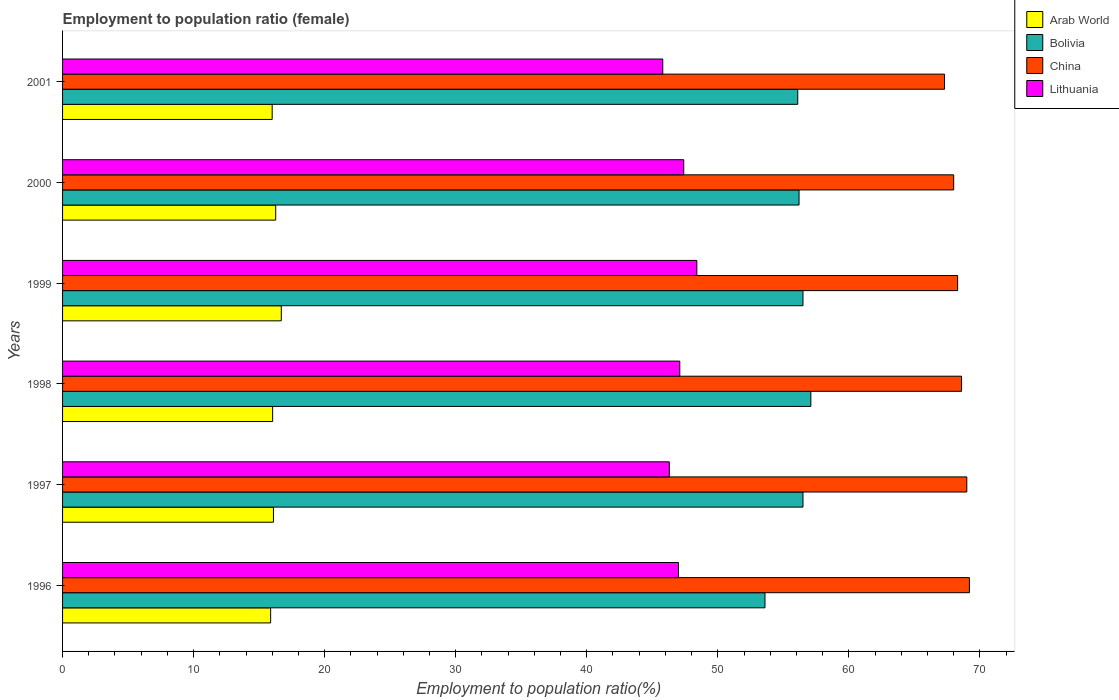How many different coloured bars are there?
Offer a very short reply. 4. What is the label of the 4th group of bars from the top?
Keep it short and to the point. 1998. What is the employment to population ratio in Bolivia in 1996?
Your answer should be very brief. 53.6. Across all years, what is the maximum employment to population ratio in Bolivia?
Ensure brevity in your answer.  57.1. Across all years, what is the minimum employment to population ratio in Arab World?
Keep it short and to the point. 15.88. In which year was the employment to population ratio in Lithuania minimum?
Ensure brevity in your answer.  2001. What is the total employment to population ratio in Arab World in the graph?
Give a very brief answer. 96.95. What is the difference between the employment to population ratio in Bolivia in 1996 and that in 1999?
Keep it short and to the point. -2.9. What is the difference between the employment to population ratio in China in 2000 and the employment to population ratio in Lithuania in 1999?
Your response must be concise. 19.6. What is the average employment to population ratio in Arab World per year?
Your answer should be very brief. 16.16. In the year 1996, what is the difference between the employment to population ratio in Bolivia and employment to population ratio in Lithuania?
Offer a terse response. 6.6. What is the ratio of the employment to population ratio in Lithuania in 1999 to that in 2001?
Your answer should be compact. 1.06. What is the difference between the highest and the second highest employment to population ratio in China?
Your response must be concise. 0.2. What is the difference between the highest and the lowest employment to population ratio in Lithuania?
Offer a very short reply. 2.6. In how many years, is the employment to population ratio in Lithuania greater than the average employment to population ratio in Lithuania taken over all years?
Ensure brevity in your answer.  4. Is the sum of the employment to population ratio in Arab World in 1997 and 1999 greater than the maximum employment to population ratio in Bolivia across all years?
Give a very brief answer. No. Are all the bars in the graph horizontal?
Your response must be concise. Yes. Are the values on the major ticks of X-axis written in scientific E-notation?
Your response must be concise. No. Does the graph contain any zero values?
Provide a succinct answer. No. Where does the legend appear in the graph?
Your answer should be compact. Top right. How many legend labels are there?
Keep it short and to the point. 4. How are the legend labels stacked?
Give a very brief answer. Vertical. What is the title of the graph?
Ensure brevity in your answer.  Employment to population ratio (female). What is the Employment to population ratio(%) in Arab World in 1996?
Offer a very short reply. 15.88. What is the Employment to population ratio(%) in Bolivia in 1996?
Provide a short and direct response. 53.6. What is the Employment to population ratio(%) in China in 1996?
Offer a very short reply. 69.2. What is the Employment to population ratio(%) in Arab World in 1997?
Your answer should be very brief. 16.09. What is the Employment to population ratio(%) in Bolivia in 1997?
Keep it short and to the point. 56.5. What is the Employment to population ratio(%) in China in 1997?
Your answer should be compact. 69. What is the Employment to population ratio(%) in Lithuania in 1997?
Your response must be concise. 46.3. What is the Employment to population ratio(%) in Arab World in 1998?
Your answer should be very brief. 16.03. What is the Employment to population ratio(%) of Bolivia in 1998?
Your answer should be very brief. 57.1. What is the Employment to population ratio(%) of China in 1998?
Offer a terse response. 68.6. What is the Employment to population ratio(%) in Lithuania in 1998?
Ensure brevity in your answer.  47.1. What is the Employment to population ratio(%) in Arab World in 1999?
Keep it short and to the point. 16.69. What is the Employment to population ratio(%) of Bolivia in 1999?
Keep it short and to the point. 56.5. What is the Employment to population ratio(%) of China in 1999?
Ensure brevity in your answer.  68.3. What is the Employment to population ratio(%) in Lithuania in 1999?
Make the answer very short. 48.4. What is the Employment to population ratio(%) in Arab World in 2000?
Your answer should be compact. 16.26. What is the Employment to population ratio(%) of Bolivia in 2000?
Offer a terse response. 56.2. What is the Employment to population ratio(%) in Lithuania in 2000?
Keep it short and to the point. 47.4. What is the Employment to population ratio(%) in Arab World in 2001?
Make the answer very short. 16. What is the Employment to population ratio(%) in Bolivia in 2001?
Your answer should be very brief. 56.1. What is the Employment to population ratio(%) of China in 2001?
Provide a short and direct response. 67.3. What is the Employment to population ratio(%) in Lithuania in 2001?
Your response must be concise. 45.8. Across all years, what is the maximum Employment to population ratio(%) in Arab World?
Your answer should be compact. 16.69. Across all years, what is the maximum Employment to population ratio(%) in Bolivia?
Offer a very short reply. 57.1. Across all years, what is the maximum Employment to population ratio(%) of China?
Give a very brief answer. 69.2. Across all years, what is the maximum Employment to population ratio(%) in Lithuania?
Provide a succinct answer. 48.4. Across all years, what is the minimum Employment to population ratio(%) of Arab World?
Keep it short and to the point. 15.88. Across all years, what is the minimum Employment to population ratio(%) in Bolivia?
Your answer should be compact. 53.6. Across all years, what is the minimum Employment to population ratio(%) in China?
Give a very brief answer. 67.3. Across all years, what is the minimum Employment to population ratio(%) in Lithuania?
Provide a short and direct response. 45.8. What is the total Employment to population ratio(%) of Arab World in the graph?
Make the answer very short. 96.95. What is the total Employment to population ratio(%) in Bolivia in the graph?
Your response must be concise. 336. What is the total Employment to population ratio(%) of China in the graph?
Your response must be concise. 410.4. What is the total Employment to population ratio(%) in Lithuania in the graph?
Offer a very short reply. 282. What is the difference between the Employment to population ratio(%) in Arab World in 1996 and that in 1997?
Offer a very short reply. -0.22. What is the difference between the Employment to population ratio(%) in Bolivia in 1996 and that in 1997?
Keep it short and to the point. -2.9. What is the difference between the Employment to population ratio(%) in Arab World in 1996 and that in 1998?
Your answer should be compact. -0.15. What is the difference between the Employment to population ratio(%) in Lithuania in 1996 and that in 1998?
Keep it short and to the point. -0.1. What is the difference between the Employment to population ratio(%) in Arab World in 1996 and that in 1999?
Provide a succinct answer. -0.81. What is the difference between the Employment to population ratio(%) of Bolivia in 1996 and that in 1999?
Offer a terse response. -2.9. What is the difference between the Employment to population ratio(%) in China in 1996 and that in 1999?
Provide a short and direct response. 0.9. What is the difference between the Employment to population ratio(%) in Lithuania in 1996 and that in 1999?
Make the answer very short. -1.4. What is the difference between the Employment to population ratio(%) in Arab World in 1996 and that in 2000?
Ensure brevity in your answer.  -0.39. What is the difference between the Employment to population ratio(%) of Arab World in 1996 and that in 2001?
Make the answer very short. -0.12. What is the difference between the Employment to population ratio(%) of Arab World in 1997 and that in 1998?
Make the answer very short. 0.06. What is the difference between the Employment to population ratio(%) of Bolivia in 1997 and that in 1998?
Ensure brevity in your answer.  -0.6. What is the difference between the Employment to population ratio(%) of China in 1997 and that in 1998?
Offer a terse response. 0.4. What is the difference between the Employment to population ratio(%) of Lithuania in 1997 and that in 1998?
Your answer should be very brief. -0.8. What is the difference between the Employment to population ratio(%) of Arab World in 1997 and that in 1999?
Ensure brevity in your answer.  -0.6. What is the difference between the Employment to population ratio(%) in Bolivia in 1997 and that in 1999?
Your response must be concise. 0. What is the difference between the Employment to population ratio(%) in China in 1997 and that in 1999?
Make the answer very short. 0.7. What is the difference between the Employment to population ratio(%) in Arab World in 1997 and that in 2000?
Make the answer very short. -0.17. What is the difference between the Employment to population ratio(%) of Bolivia in 1997 and that in 2000?
Your answer should be very brief. 0.3. What is the difference between the Employment to population ratio(%) in China in 1997 and that in 2000?
Your answer should be compact. 1. What is the difference between the Employment to population ratio(%) in Lithuania in 1997 and that in 2000?
Make the answer very short. -1.1. What is the difference between the Employment to population ratio(%) in Arab World in 1997 and that in 2001?
Your response must be concise. 0.1. What is the difference between the Employment to population ratio(%) in China in 1997 and that in 2001?
Offer a very short reply. 1.7. What is the difference between the Employment to population ratio(%) in Lithuania in 1997 and that in 2001?
Give a very brief answer. 0.5. What is the difference between the Employment to population ratio(%) in Arab World in 1998 and that in 1999?
Provide a succinct answer. -0.66. What is the difference between the Employment to population ratio(%) in China in 1998 and that in 1999?
Ensure brevity in your answer.  0.3. What is the difference between the Employment to population ratio(%) of Lithuania in 1998 and that in 1999?
Keep it short and to the point. -1.3. What is the difference between the Employment to population ratio(%) in Arab World in 1998 and that in 2000?
Your response must be concise. -0.23. What is the difference between the Employment to population ratio(%) in China in 1998 and that in 2000?
Provide a short and direct response. 0.6. What is the difference between the Employment to population ratio(%) in Lithuania in 1998 and that in 2000?
Ensure brevity in your answer.  -0.3. What is the difference between the Employment to population ratio(%) of Arab World in 1998 and that in 2001?
Offer a terse response. 0.04. What is the difference between the Employment to population ratio(%) of China in 1998 and that in 2001?
Make the answer very short. 1.3. What is the difference between the Employment to population ratio(%) in Arab World in 1999 and that in 2000?
Your answer should be compact. 0.43. What is the difference between the Employment to population ratio(%) of Bolivia in 1999 and that in 2000?
Give a very brief answer. 0.3. What is the difference between the Employment to population ratio(%) of China in 1999 and that in 2000?
Offer a terse response. 0.3. What is the difference between the Employment to population ratio(%) of Arab World in 1999 and that in 2001?
Your answer should be very brief. 0.7. What is the difference between the Employment to population ratio(%) of Bolivia in 1999 and that in 2001?
Ensure brevity in your answer.  0.4. What is the difference between the Employment to population ratio(%) in China in 1999 and that in 2001?
Your answer should be compact. 1. What is the difference between the Employment to population ratio(%) in Arab World in 2000 and that in 2001?
Provide a succinct answer. 0.27. What is the difference between the Employment to population ratio(%) of China in 2000 and that in 2001?
Make the answer very short. 0.7. What is the difference between the Employment to population ratio(%) in Lithuania in 2000 and that in 2001?
Offer a very short reply. 1.6. What is the difference between the Employment to population ratio(%) in Arab World in 1996 and the Employment to population ratio(%) in Bolivia in 1997?
Your answer should be compact. -40.62. What is the difference between the Employment to population ratio(%) of Arab World in 1996 and the Employment to population ratio(%) of China in 1997?
Offer a terse response. -53.12. What is the difference between the Employment to population ratio(%) in Arab World in 1996 and the Employment to population ratio(%) in Lithuania in 1997?
Provide a succinct answer. -30.42. What is the difference between the Employment to population ratio(%) of Bolivia in 1996 and the Employment to population ratio(%) of China in 1997?
Your answer should be very brief. -15.4. What is the difference between the Employment to population ratio(%) in Bolivia in 1996 and the Employment to population ratio(%) in Lithuania in 1997?
Offer a terse response. 7.3. What is the difference between the Employment to population ratio(%) in China in 1996 and the Employment to population ratio(%) in Lithuania in 1997?
Provide a succinct answer. 22.9. What is the difference between the Employment to population ratio(%) of Arab World in 1996 and the Employment to population ratio(%) of Bolivia in 1998?
Your response must be concise. -41.22. What is the difference between the Employment to population ratio(%) of Arab World in 1996 and the Employment to population ratio(%) of China in 1998?
Your response must be concise. -52.72. What is the difference between the Employment to population ratio(%) in Arab World in 1996 and the Employment to population ratio(%) in Lithuania in 1998?
Ensure brevity in your answer.  -31.22. What is the difference between the Employment to population ratio(%) in Bolivia in 1996 and the Employment to population ratio(%) in China in 1998?
Provide a short and direct response. -15. What is the difference between the Employment to population ratio(%) in Bolivia in 1996 and the Employment to population ratio(%) in Lithuania in 1998?
Provide a short and direct response. 6.5. What is the difference between the Employment to population ratio(%) of China in 1996 and the Employment to population ratio(%) of Lithuania in 1998?
Provide a short and direct response. 22.1. What is the difference between the Employment to population ratio(%) of Arab World in 1996 and the Employment to population ratio(%) of Bolivia in 1999?
Provide a succinct answer. -40.62. What is the difference between the Employment to population ratio(%) of Arab World in 1996 and the Employment to population ratio(%) of China in 1999?
Provide a short and direct response. -52.42. What is the difference between the Employment to population ratio(%) in Arab World in 1996 and the Employment to population ratio(%) in Lithuania in 1999?
Your answer should be compact. -32.52. What is the difference between the Employment to population ratio(%) of Bolivia in 1996 and the Employment to population ratio(%) of China in 1999?
Your response must be concise. -14.7. What is the difference between the Employment to population ratio(%) in Bolivia in 1996 and the Employment to population ratio(%) in Lithuania in 1999?
Your response must be concise. 5.2. What is the difference between the Employment to population ratio(%) of China in 1996 and the Employment to population ratio(%) of Lithuania in 1999?
Keep it short and to the point. 20.8. What is the difference between the Employment to population ratio(%) of Arab World in 1996 and the Employment to population ratio(%) of Bolivia in 2000?
Keep it short and to the point. -40.32. What is the difference between the Employment to population ratio(%) in Arab World in 1996 and the Employment to population ratio(%) in China in 2000?
Offer a terse response. -52.12. What is the difference between the Employment to population ratio(%) in Arab World in 1996 and the Employment to population ratio(%) in Lithuania in 2000?
Make the answer very short. -31.52. What is the difference between the Employment to population ratio(%) of Bolivia in 1996 and the Employment to population ratio(%) of China in 2000?
Your answer should be compact. -14.4. What is the difference between the Employment to population ratio(%) in China in 1996 and the Employment to population ratio(%) in Lithuania in 2000?
Give a very brief answer. 21.8. What is the difference between the Employment to population ratio(%) of Arab World in 1996 and the Employment to population ratio(%) of Bolivia in 2001?
Offer a terse response. -40.22. What is the difference between the Employment to population ratio(%) in Arab World in 1996 and the Employment to population ratio(%) in China in 2001?
Make the answer very short. -51.42. What is the difference between the Employment to population ratio(%) of Arab World in 1996 and the Employment to population ratio(%) of Lithuania in 2001?
Ensure brevity in your answer.  -29.92. What is the difference between the Employment to population ratio(%) in Bolivia in 1996 and the Employment to population ratio(%) in China in 2001?
Your answer should be compact. -13.7. What is the difference between the Employment to population ratio(%) in China in 1996 and the Employment to population ratio(%) in Lithuania in 2001?
Provide a short and direct response. 23.4. What is the difference between the Employment to population ratio(%) in Arab World in 1997 and the Employment to population ratio(%) in Bolivia in 1998?
Your answer should be very brief. -41.01. What is the difference between the Employment to population ratio(%) of Arab World in 1997 and the Employment to population ratio(%) of China in 1998?
Your response must be concise. -52.51. What is the difference between the Employment to population ratio(%) of Arab World in 1997 and the Employment to population ratio(%) of Lithuania in 1998?
Keep it short and to the point. -31.01. What is the difference between the Employment to population ratio(%) in China in 1997 and the Employment to population ratio(%) in Lithuania in 1998?
Provide a succinct answer. 21.9. What is the difference between the Employment to population ratio(%) in Arab World in 1997 and the Employment to population ratio(%) in Bolivia in 1999?
Offer a very short reply. -40.41. What is the difference between the Employment to population ratio(%) in Arab World in 1997 and the Employment to population ratio(%) in China in 1999?
Provide a succinct answer. -52.21. What is the difference between the Employment to population ratio(%) in Arab World in 1997 and the Employment to population ratio(%) in Lithuania in 1999?
Your response must be concise. -32.31. What is the difference between the Employment to population ratio(%) of Bolivia in 1997 and the Employment to population ratio(%) of Lithuania in 1999?
Offer a very short reply. 8.1. What is the difference between the Employment to population ratio(%) of China in 1997 and the Employment to population ratio(%) of Lithuania in 1999?
Your response must be concise. 20.6. What is the difference between the Employment to population ratio(%) of Arab World in 1997 and the Employment to population ratio(%) of Bolivia in 2000?
Your answer should be very brief. -40.11. What is the difference between the Employment to population ratio(%) in Arab World in 1997 and the Employment to population ratio(%) in China in 2000?
Keep it short and to the point. -51.91. What is the difference between the Employment to population ratio(%) in Arab World in 1997 and the Employment to population ratio(%) in Lithuania in 2000?
Provide a succinct answer. -31.31. What is the difference between the Employment to population ratio(%) in Bolivia in 1997 and the Employment to population ratio(%) in Lithuania in 2000?
Provide a short and direct response. 9.1. What is the difference between the Employment to population ratio(%) of China in 1997 and the Employment to population ratio(%) of Lithuania in 2000?
Ensure brevity in your answer.  21.6. What is the difference between the Employment to population ratio(%) of Arab World in 1997 and the Employment to population ratio(%) of Bolivia in 2001?
Provide a short and direct response. -40.01. What is the difference between the Employment to population ratio(%) in Arab World in 1997 and the Employment to population ratio(%) in China in 2001?
Give a very brief answer. -51.21. What is the difference between the Employment to population ratio(%) in Arab World in 1997 and the Employment to population ratio(%) in Lithuania in 2001?
Your answer should be very brief. -29.71. What is the difference between the Employment to population ratio(%) in Bolivia in 1997 and the Employment to population ratio(%) in Lithuania in 2001?
Keep it short and to the point. 10.7. What is the difference between the Employment to population ratio(%) in China in 1997 and the Employment to population ratio(%) in Lithuania in 2001?
Ensure brevity in your answer.  23.2. What is the difference between the Employment to population ratio(%) of Arab World in 1998 and the Employment to population ratio(%) of Bolivia in 1999?
Your response must be concise. -40.47. What is the difference between the Employment to population ratio(%) in Arab World in 1998 and the Employment to population ratio(%) in China in 1999?
Make the answer very short. -52.27. What is the difference between the Employment to population ratio(%) in Arab World in 1998 and the Employment to population ratio(%) in Lithuania in 1999?
Make the answer very short. -32.37. What is the difference between the Employment to population ratio(%) in Bolivia in 1998 and the Employment to population ratio(%) in China in 1999?
Give a very brief answer. -11.2. What is the difference between the Employment to population ratio(%) in China in 1998 and the Employment to population ratio(%) in Lithuania in 1999?
Your response must be concise. 20.2. What is the difference between the Employment to population ratio(%) of Arab World in 1998 and the Employment to population ratio(%) of Bolivia in 2000?
Your answer should be compact. -40.17. What is the difference between the Employment to population ratio(%) of Arab World in 1998 and the Employment to population ratio(%) of China in 2000?
Your answer should be very brief. -51.97. What is the difference between the Employment to population ratio(%) in Arab World in 1998 and the Employment to population ratio(%) in Lithuania in 2000?
Give a very brief answer. -31.37. What is the difference between the Employment to population ratio(%) in Bolivia in 1998 and the Employment to population ratio(%) in China in 2000?
Offer a terse response. -10.9. What is the difference between the Employment to population ratio(%) of China in 1998 and the Employment to population ratio(%) of Lithuania in 2000?
Make the answer very short. 21.2. What is the difference between the Employment to population ratio(%) in Arab World in 1998 and the Employment to population ratio(%) in Bolivia in 2001?
Provide a succinct answer. -40.07. What is the difference between the Employment to population ratio(%) of Arab World in 1998 and the Employment to population ratio(%) of China in 2001?
Provide a short and direct response. -51.27. What is the difference between the Employment to population ratio(%) of Arab World in 1998 and the Employment to population ratio(%) of Lithuania in 2001?
Your answer should be very brief. -29.77. What is the difference between the Employment to population ratio(%) of Bolivia in 1998 and the Employment to population ratio(%) of China in 2001?
Your answer should be compact. -10.2. What is the difference between the Employment to population ratio(%) of China in 1998 and the Employment to population ratio(%) of Lithuania in 2001?
Offer a terse response. 22.8. What is the difference between the Employment to population ratio(%) of Arab World in 1999 and the Employment to population ratio(%) of Bolivia in 2000?
Your answer should be very brief. -39.51. What is the difference between the Employment to population ratio(%) in Arab World in 1999 and the Employment to population ratio(%) in China in 2000?
Make the answer very short. -51.31. What is the difference between the Employment to population ratio(%) of Arab World in 1999 and the Employment to population ratio(%) of Lithuania in 2000?
Provide a succinct answer. -30.71. What is the difference between the Employment to population ratio(%) in Bolivia in 1999 and the Employment to population ratio(%) in China in 2000?
Your response must be concise. -11.5. What is the difference between the Employment to population ratio(%) in China in 1999 and the Employment to population ratio(%) in Lithuania in 2000?
Offer a very short reply. 20.9. What is the difference between the Employment to population ratio(%) in Arab World in 1999 and the Employment to population ratio(%) in Bolivia in 2001?
Offer a terse response. -39.41. What is the difference between the Employment to population ratio(%) in Arab World in 1999 and the Employment to population ratio(%) in China in 2001?
Your answer should be compact. -50.61. What is the difference between the Employment to population ratio(%) of Arab World in 1999 and the Employment to population ratio(%) of Lithuania in 2001?
Your response must be concise. -29.11. What is the difference between the Employment to population ratio(%) in China in 1999 and the Employment to population ratio(%) in Lithuania in 2001?
Ensure brevity in your answer.  22.5. What is the difference between the Employment to population ratio(%) in Arab World in 2000 and the Employment to population ratio(%) in Bolivia in 2001?
Give a very brief answer. -39.84. What is the difference between the Employment to population ratio(%) of Arab World in 2000 and the Employment to population ratio(%) of China in 2001?
Ensure brevity in your answer.  -51.04. What is the difference between the Employment to population ratio(%) of Arab World in 2000 and the Employment to population ratio(%) of Lithuania in 2001?
Provide a short and direct response. -29.54. What is the difference between the Employment to population ratio(%) of China in 2000 and the Employment to population ratio(%) of Lithuania in 2001?
Your answer should be compact. 22.2. What is the average Employment to population ratio(%) of Arab World per year?
Make the answer very short. 16.16. What is the average Employment to population ratio(%) in Bolivia per year?
Give a very brief answer. 56. What is the average Employment to population ratio(%) in China per year?
Your answer should be compact. 68.4. In the year 1996, what is the difference between the Employment to population ratio(%) in Arab World and Employment to population ratio(%) in Bolivia?
Provide a short and direct response. -37.72. In the year 1996, what is the difference between the Employment to population ratio(%) in Arab World and Employment to population ratio(%) in China?
Give a very brief answer. -53.32. In the year 1996, what is the difference between the Employment to population ratio(%) in Arab World and Employment to population ratio(%) in Lithuania?
Ensure brevity in your answer.  -31.12. In the year 1996, what is the difference between the Employment to population ratio(%) of Bolivia and Employment to population ratio(%) of China?
Your answer should be compact. -15.6. In the year 1996, what is the difference between the Employment to population ratio(%) in Bolivia and Employment to population ratio(%) in Lithuania?
Provide a short and direct response. 6.6. In the year 1997, what is the difference between the Employment to population ratio(%) in Arab World and Employment to population ratio(%) in Bolivia?
Your answer should be compact. -40.41. In the year 1997, what is the difference between the Employment to population ratio(%) in Arab World and Employment to population ratio(%) in China?
Offer a very short reply. -52.91. In the year 1997, what is the difference between the Employment to population ratio(%) in Arab World and Employment to population ratio(%) in Lithuania?
Your response must be concise. -30.21. In the year 1997, what is the difference between the Employment to population ratio(%) of Bolivia and Employment to population ratio(%) of China?
Your answer should be very brief. -12.5. In the year 1997, what is the difference between the Employment to population ratio(%) of China and Employment to population ratio(%) of Lithuania?
Make the answer very short. 22.7. In the year 1998, what is the difference between the Employment to population ratio(%) of Arab World and Employment to population ratio(%) of Bolivia?
Keep it short and to the point. -41.07. In the year 1998, what is the difference between the Employment to population ratio(%) of Arab World and Employment to population ratio(%) of China?
Make the answer very short. -52.57. In the year 1998, what is the difference between the Employment to population ratio(%) of Arab World and Employment to population ratio(%) of Lithuania?
Your answer should be very brief. -31.07. In the year 1998, what is the difference between the Employment to population ratio(%) in Bolivia and Employment to population ratio(%) in China?
Your answer should be compact. -11.5. In the year 1998, what is the difference between the Employment to population ratio(%) of Bolivia and Employment to population ratio(%) of Lithuania?
Give a very brief answer. 10. In the year 1999, what is the difference between the Employment to population ratio(%) in Arab World and Employment to population ratio(%) in Bolivia?
Ensure brevity in your answer.  -39.81. In the year 1999, what is the difference between the Employment to population ratio(%) in Arab World and Employment to population ratio(%) in China?
Your answer should be very brief. -51.61. In the year 1999, what is the difference between the Employment to population ratio(%) in Arab World and Employment to population ratio(%) in Lithuania?
Provide a succinct answer. -31.71. In the year 1999, what is the difference between the Employment to population ratio(%) in Bolivia and Employment to population ratio(%) in China?
Your response must be concise. -11.8. In the year 2000, what is the difference between the Employment to population ratio(%) of Arab World and Employment to population ratio(%) of Bolivia?
Your answer should be very brief. -39.94. In the year 2000, what is the difference between the Employment to population ratio(%) in Arab World and Employment to population ratio(%) in China?
Keep it short and to the point. -51.74. In the year 2000, what is the difference between the Employment to population ratio(%) in Arab World and Employment to population ratio(%) in Lithuania?
Your answer should be compact. -31.14. In the year 2000, what is the difference between the Employment to population ratio(%) in China and Employment to population ratio(%) in Lithuania?
Ensure brevity in your answer.  20.6. In the year 2001, what is the difference between the Employment to population ratio(%) of Arab World and Employment to population ratio(%) of Bolivia?
Your answer should be very brief. -40.1. In the year 2001, what is the difference between the Employment to population ratio(%) in Arab World and Employment to population ratio(%) in China?
Offer a very short reply. -51.3. In the year 2001, what is the difference between the Employment to population ratio(%) of Arab World and Employment to population ratio(%) of Lithuania?
Provide a succinct answer. -29.8. In the year 2001, what is the difference between the Employment to population ratio(%) in Bolivia and Employment to population ratio(%) in China?
Your answer should be very brief. -11.2. What is the ratio of the Employment to population ratio(%) of Arab World in 1996 to that in 1997?
Your answer should be compact. 0.99. What is the ratio of the Employment to population ratio(%) of Bolivia in 1996 to that in 1997?
Make the answer very short. 0.95. What is the ratio of the Employment to population ratio(%) of Lithuania in 1996 to that in 1997?
Provide a short and direct response. 1.02. What is the ratio of the Employment to population ratio(%) in Bolivia in 1996 to that in 1998?
Your response must be concise. 0.94. What is the ratio of the Employment to population ratio(%) of China in 1996 to that in 1998?
Offer a terse response. 1.01. What is the ratio of the Employment to population ratio(%) in Arab World in 1996 to that in 1999?
Make the answer very short. 0.95. What is the ratio of the Employment to population ratio(%) in Bolivia in 1996 to that in 1999?
Your answer should be very brief. 0.95. What is the ratio of the Employment to population ratio(%) in China in 1996 to that in 1999?
Make the answer very short. 1.01. What is the ratio of the Employment to population ratio(%) of Lithuania in 1996 to that in 1999?
Your answer should be very brief. 0.97. What is the ratio of the Employment to population ratio(%) in Arab World in 1996 to that in 2000?
Provide a succinct answer. 0.98. What is the ratio of the Employment to population ratio(%) in Bolivia in 1996 to that in 2000?
Your answer should be very brief. 0.95. What is the ratio of the Employment to population ratio(%) of China in 1996 to that in 2000?
Keep it short and to the point. 1.02. What is the ratio of the Employment to population ratio(%) in Arab World in 1996 to that in 2001?
Provide a short and direct response. 0.99. What is the ratio of the Employment to population ratio(%) in Bolivia in 1996 to that in 2001?
Provide a succinct answer. 0.96. What is the ratio of the Employment to population ratio(%) in China in 1996 to that in 2001?
Keep it short and to the point. 1.03. What is the ratio of the Employment to population ratio(%) of Lithuania in 1996 to that in 2001?
Provide a succinct answer. 1.03. What is the ratio of the Employment to population ratio(%) of China in 1997 to that in 1998?
Your response must be concise. 1.01. What is the ratio of the Employment to population ratio(%) of Arab World in 1997 to that in 1999?
Ensure brevity in your answer.  0.96. What is the ratio of the Employment to population ratio(%) in China in 1997 to that in 1999?
Provide a short and direct response. 1.01. What is the ratio of the Employment to population ratio(%) in Lithuania in 1997 to that in 1999?
Offer a terse response. 0.96. What is the ratio of the Employment to population ratio(%) in Arab World in 1997 to that in 2000?
Ensure brevity in your answer.  0.99. What is the ratio of the Employment to population ratio(%) of Bolivia in 1997 to that in 2000?
Provide a short and direct response. 1.01. What is the ratio of the Employment to population ratio(%) in China in 1997 to that in 2000?
Your answer should be very brief. 1.01. What is the ratio of the Employment to population ratio(%) of Lithuania in 1997 to that in 2000?
Give a very brief answer. 0.98. What is the ratio of the Employment to population ratio(%) of Bolivia in 1997 to that in 2001?
Provide a short and direct response. 1.01. What is the ratio of the Employment to population ratio(%) in China in 1997 to that in 2001?
Ensure brevity in your answer.  1.03. What is the ratio of the Employment to population ratio(%) in Lithuania in 1997 to that in 2001?
Your answer should be compact. 1.01. What is the ratio of the Employment to population ratio(%) in Arab World in 1998 to that in 1999?
Make the answer very short. 0.96. What is the ratio of the Employment to population ratio(%) of Bolivia in 1998 to that in 1999?
Ensure brevity in your answer.  1.01. What is the ratio of the Employment to population ratio(%) of Lithuania in 1998 to that in 1999?
Offer a terse response. 0.97. What is the ratio of the Employment to population ratio(%) in Arab World in 1998 to that in 2000?
Your response must be concise. 0.99. What is the ratio of the Employment to population ratio(%) of Bolivia in 1998 to that in 2000?
Your answer should be very brief. 1.02. What is the ratio of the Employment to population ratio(%) of China in 1998 to that in 2000?
Give a very brief answer. 1.01. What is the ratio of the Employment to population ratio(%) of Lithuania in 1998 to that in 2000?
Make the answer very short. 0.99. What is the ratio of the Employment to population ratio(%) of Bolivia in 1998 to that in 2001?
Offer a very short reply. 1.02. What is the ratio of the Employment to population ratio(%) in China in 1998 to that in 2001?
Keep it short and to the point. 1.02. What is the ratio of the Employment to population ratio(%) in Lithuania in 1998 to that in 2001?
Your answer should be compact. 1.03. What is the ratio of the Employment to population ratio(%) in Arab World in 1999 to that in 2000?
Ensure brevity in your answer.  1.03. What is the ratio of the Employment to population ratio(%) of Lithuania in 1999 to that in 2000?
Your response must be concise. 1.02. What is the ratio of the Employment to population ratio(%) in Arab World in 1999 to that in 2001?
Your response must be concise. 1.04. What is the ratio of the Employment to population ratio(%) of Bolivia in 1999 to that in 2001?
Ensure brevity in your answer.  1.01. What is the ratio of the Employment to population ratio(%) of China in 1999 to that in 2001?
Your response must be concise. 1.01. What is the ratio of the Employment to population ratio(%) of Lithuania in 1999 to that in 2001?
Ensure brevity in your answer.  1.06. What is the ratio of the Employment to population ratio(%) in Arab World in 2000 to that in 2001?
Your response must be concise. 1.02. What is the ratio of the Employment to population ratio(%) in China in 2000 to that in 2001?
Provide a short and direct response. 1.01. What is the ratio of the Employment to population ratio(%) of Lithuania in 2000 to that in 2001?
Offer a very short reply. 1.03. What is the difference between the highest and the second highest Employment to population ratio(%) of Arab World?
Your answer should be very brief. 0.43. What is the difference between the highest and the second highest Employment to population ratio(%) of China?
Make the answer very short. 0.2. What is the difference between the highest and the lowest Employment to population ratio(%) of Arab World?
Give a very brief answer. 0.81. What is the difference between the highest and the lowest Employment to population ratio(%) in Bolivia?
Make the answer very short. 3.5. What is the difference between the highest and the lowest Employment to population ratio(%) of China?
Offer a very short reply. 1.9. What is the difference between the highest and the lowest Employment to population ratio(%) of Lithuania?
Keep it short and to the point. 2.6. 